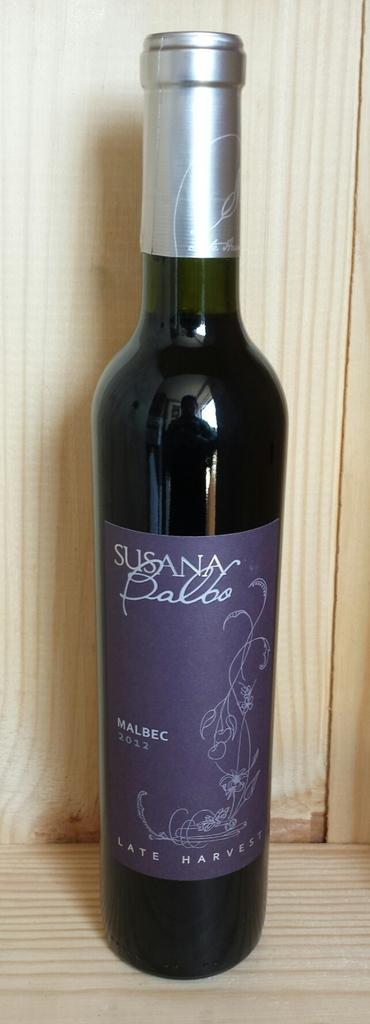What object is present in the image? There is a bottle in the image. What can be seen on the surface of the bottle? There is a reflection of a person standing on the bottle. Is there any additional decoration or labeling on the bottle? Yes, there is a sticker on the bottle. How many potatoes can be seen in the image? There are no potatoes present in the image. Can you describe the sneeze of the person reflected on the bottle? There is no sneeze depicted in the image; it only shows a reflection of a person standing on the bottle. 